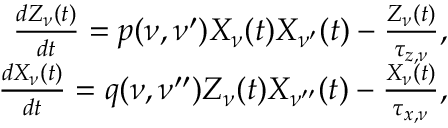<formula> <loc_0><loc_0><loc_500><loc_500>\begin{array} { r } { \frac { d Z _ { \nu } ( t ) } { d t } = p ( \nu , \nu ^ { \prime } ) X _ { \nu } ( t ) X _ { \nu ^ { \prime } } ( t ) - \frac { Z _ { \nu } ( t ) } { \tau _ { z , \nu } } , } \\ { \frac { d X _ { \nu } ( t ) } { d t } = q ( \nu , \nu ^ { \prime \prime } ) Z _ { \nu } ( t ) X _ { \nu ^ { \prime \prime } } ( t ) - \frac { X _ { \nu } ( t ) } { \tau _ { x , \nu } } , } \end{array}</formula> 